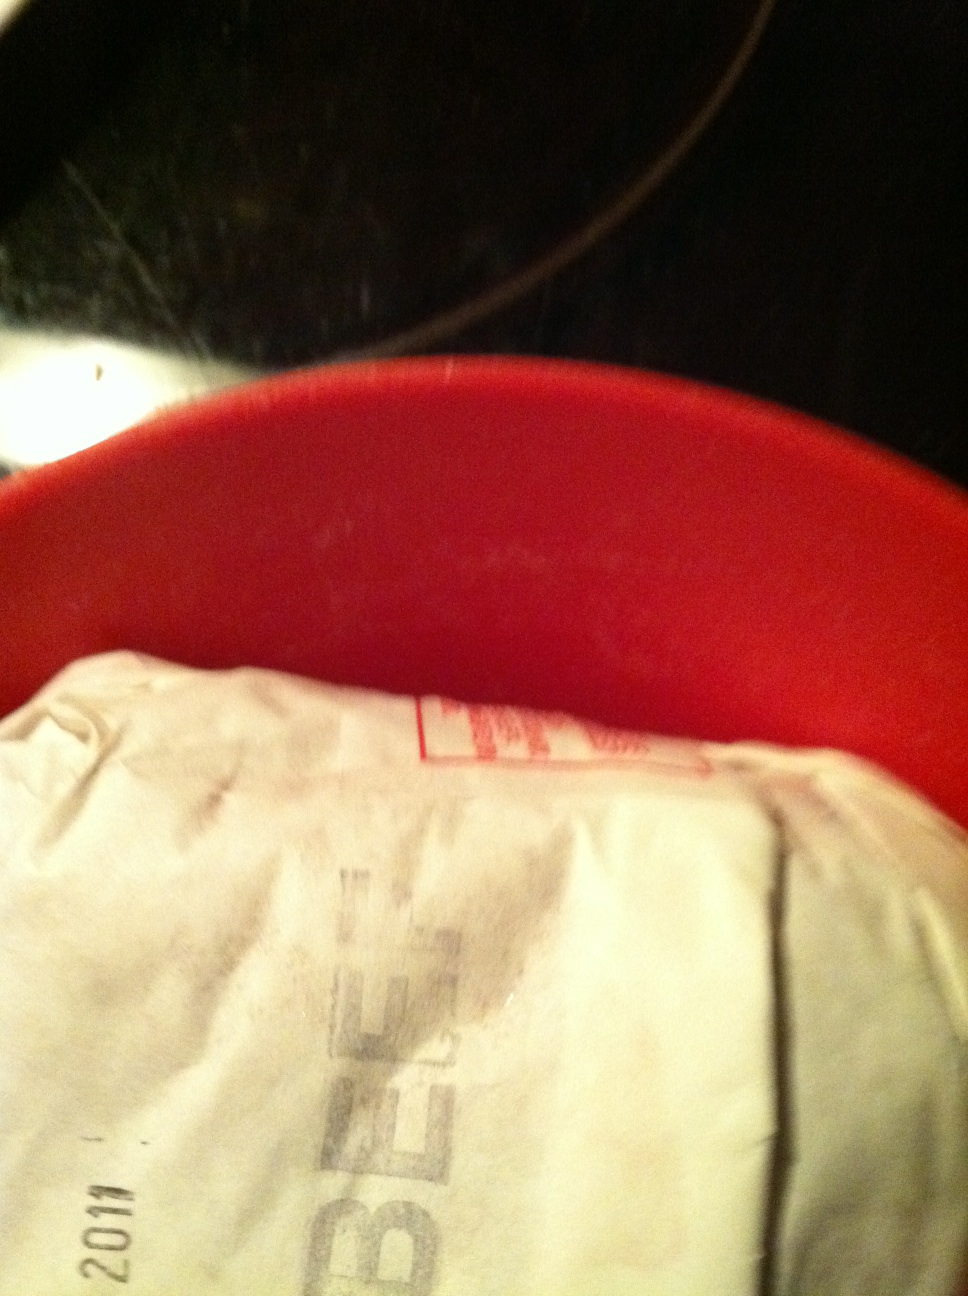What do you think this package of meat will be used for? This package of beef might be used for a variety of delicious dishes! It could be the star ingredient in a hearty beef stew, a sizzling steak on the grill, or perhaps minced into ground beef for a juicy hamburger. The possibilities are endless! Can you give me a detailed beef stew recipe? Certainly! Here's a delicious and detailed beef stew recipe for you:

Ingredients:

- 2 lbs beef chuck, cut into 1-inch cubes
- Salt and pepper, to taste
- 3 tbsp olive oil
- 2 large onions, diced
- 4 cloves garlic, minced
- 4 carrots, sliced
- 4 stalks celery, sliced
- 3 tbsp all-purpose flour
- 1/4 cup tomato paste
- 1 cup red wine
- 4 cups beef broth
- 2 bay leaves
- 1 tsp dried thyme
- 1 tsp dried rosemary
- 4 large potatoes, peeled and cubed
- 1 cup frozen peas
- Fresh parsley, chopped, for garnish

Instructions:

1. Season the beef cubes with salt and pepper.
2. Heat olive oil in a large pot over medium-high heat. Sear the beef cubes until browned on all sides. Remove and set aside.
3. In the sharegpt4v/same pot, add the onions, garlic, carrots, and celery. Cook until softened.
4. Sprinkle the flour over the vegetables and stir to combine. Cook for another minute.
5. Add the tomato paste and stir well.
6. Pour in the red wine, scraping up any browned bits from the bottom of the pot.
7. Return the beef to the pot. Add the beef broth, bay leaves, thyme, and rosemary. Bring to a boil, then reduce heat to a simmer.
8. Cover and cook for 2 hours, stirring occasionally, until the beef is tender.
9. Add the potatoes and cook for another 30 minutes, until they are tender.
10. Stir in the frozen peas and cook for another 5 minutes.
11. Garnish with fresh parsley and serve hot. Enjoy your hearty beef stew! 